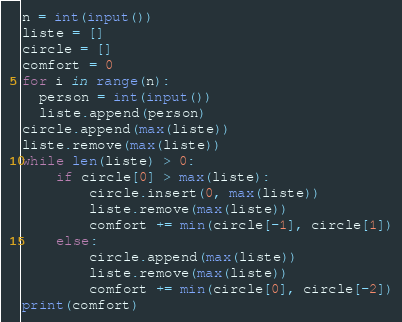<code> <loc_0><loc_0><loc_500><loc_500><_Python_>n = int(input())
liste = []
circle = []
comfort = 0
for i in range(n):
  person = int(input())
  liste.append(person)
circle.append(max(liste))
liste.remove(max(liste))
while len(liste) > 0:
    if circle[0] > max(liste):    
        circle.insert(0, max(liste))
        liste.remove(max(liste))
        comfort += min(circle[-1], circle[1])
    else:    
        circle.append(max(liste))
        liste.remove(max(liste))
        comfort += min(circle[0], circle[-2])
print(comfort)
</code> 